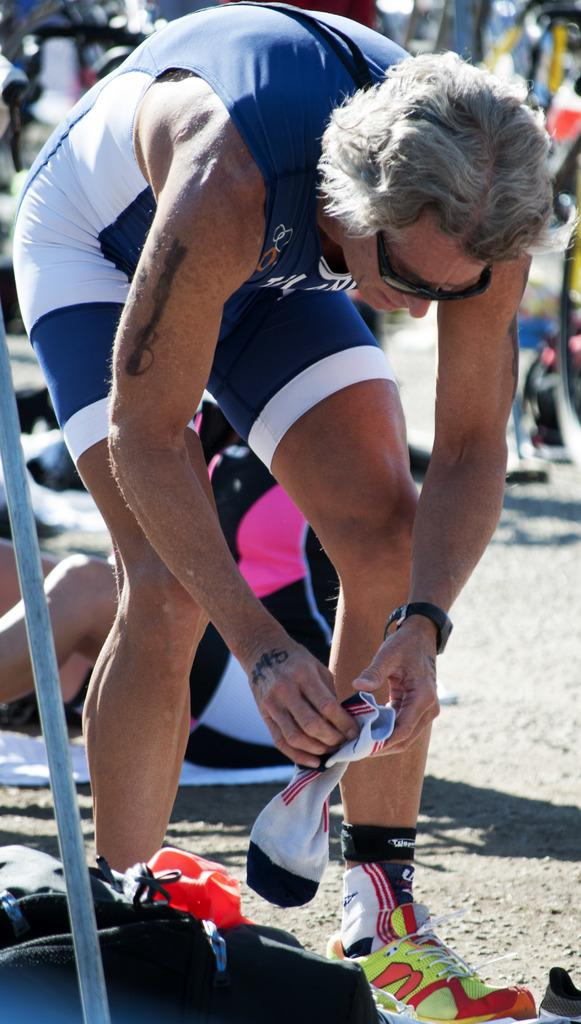Who is the main subject in the image? There is a person in the image. What is the person holding in the image? The person is holding socks. Can you describe the background of the image? There are other people visible in the background of the image. What rule does the person's grandmother enforce in the image? There is no mention of a grandmother or any rules in the image. 